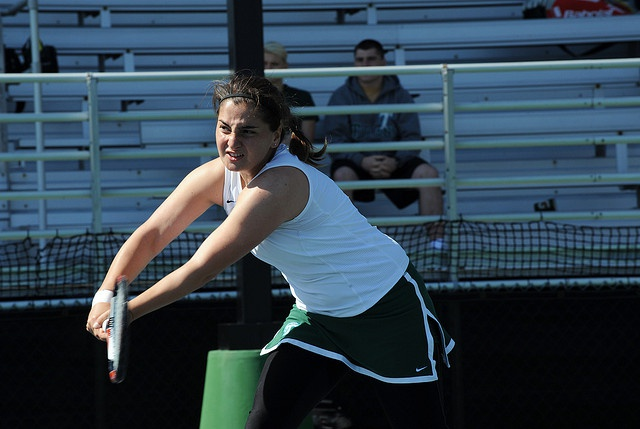Describe the objects in this image and their specific colors. I can see people in gray, black, darkgray, and ivory tones, people in gray, black, teal, and navy tones, bench in gray and blue tones, people in gray, black, teal, and blue tones, and bench in gray and blue tones in this image. 